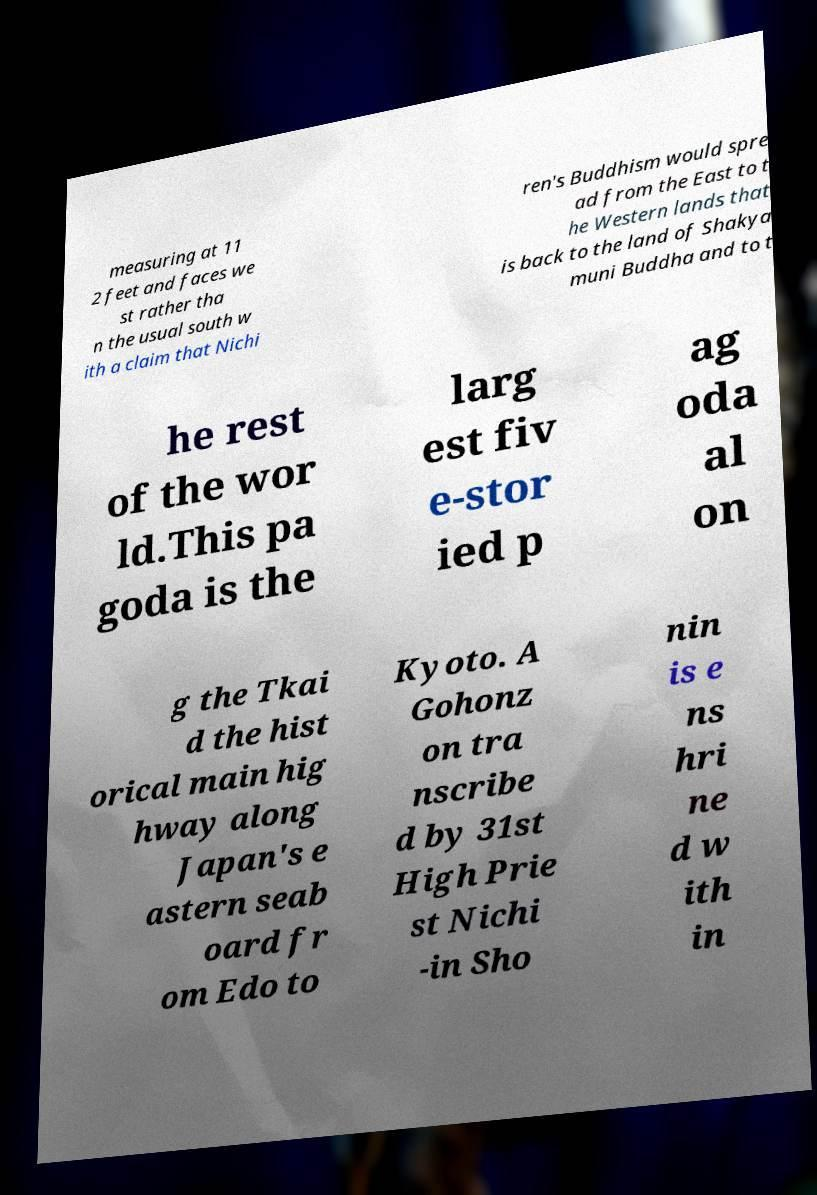Could you assist in decoding the text presented in this image and type it out clearly? measuring at 11 2 feet and faces we st rather tha n the usual south w ith a claim that Nichi ren's Buddhism would spre ad from the East to t he Western lands that is back to the land of Shakya muni Buddha and to t he rest of the wor ld.This pa goda is the larg est fiv e-stor ied p ag oda al on g the Tkai d the hist orical main hig hway along Japan's e astern seab oard fr om Edo to Kyoto. A Gohonz on tra nscribe d by 31st High Prie st Nichi -in Sho nin is e ns hri ne d w ith in 